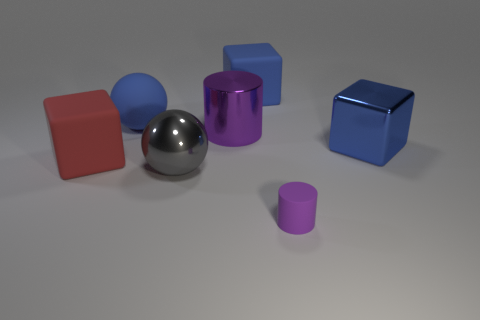Subtract all blue metallic blocks. How many blocks are left? 2 Subtract all red cubes. How many cubes are left? 2 Add 2 big purple cylinders. How many objects exist? 9 Subtract 1 spheres. How many spheres are left? 1 Subtract all cylinders. How many objects are left? 5 Subtract all gray spheres. Subtract all red cylinders. How many spheres are left? 1 Subtract all red spheres. How many blue blocks are left? 2 Subtract all purple rubber cylinders. Subtract all large matte blocks. How many objects are left? 4 Add 4 big cubes. How many big cubes are left? 7 Add 7 cubes. How many cubes exist? 10 